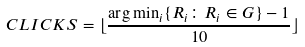Convert formula to latex. <formula><loc_0><loc_0><loc_500><loc_500>C L I C K S = \lfloor \frac { \arg \min _ { i } \{ R _ { i } \colon R _ { i } \in G \} - 1 } { 1 0 } \rfloor</formula> 